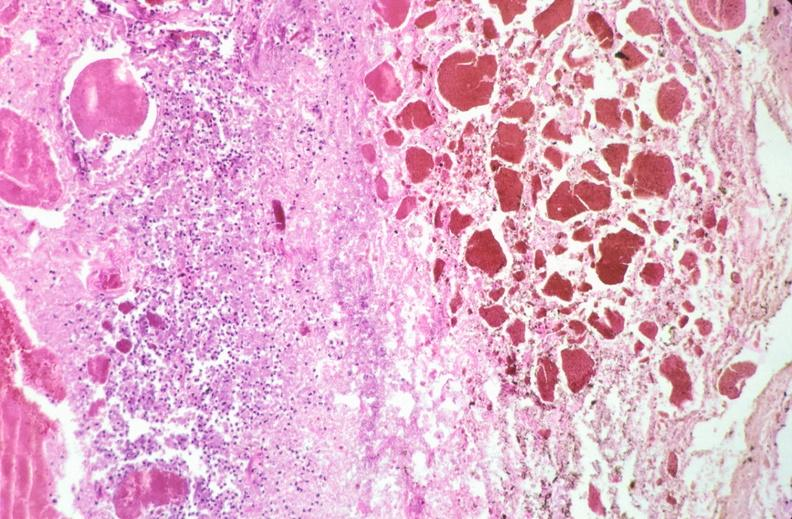does this image show stomach, necrotizing esophagitis and gastritis, sulfuric acid ingested as suicide attempt?
Answer the question using a single word or phrase. Yes 